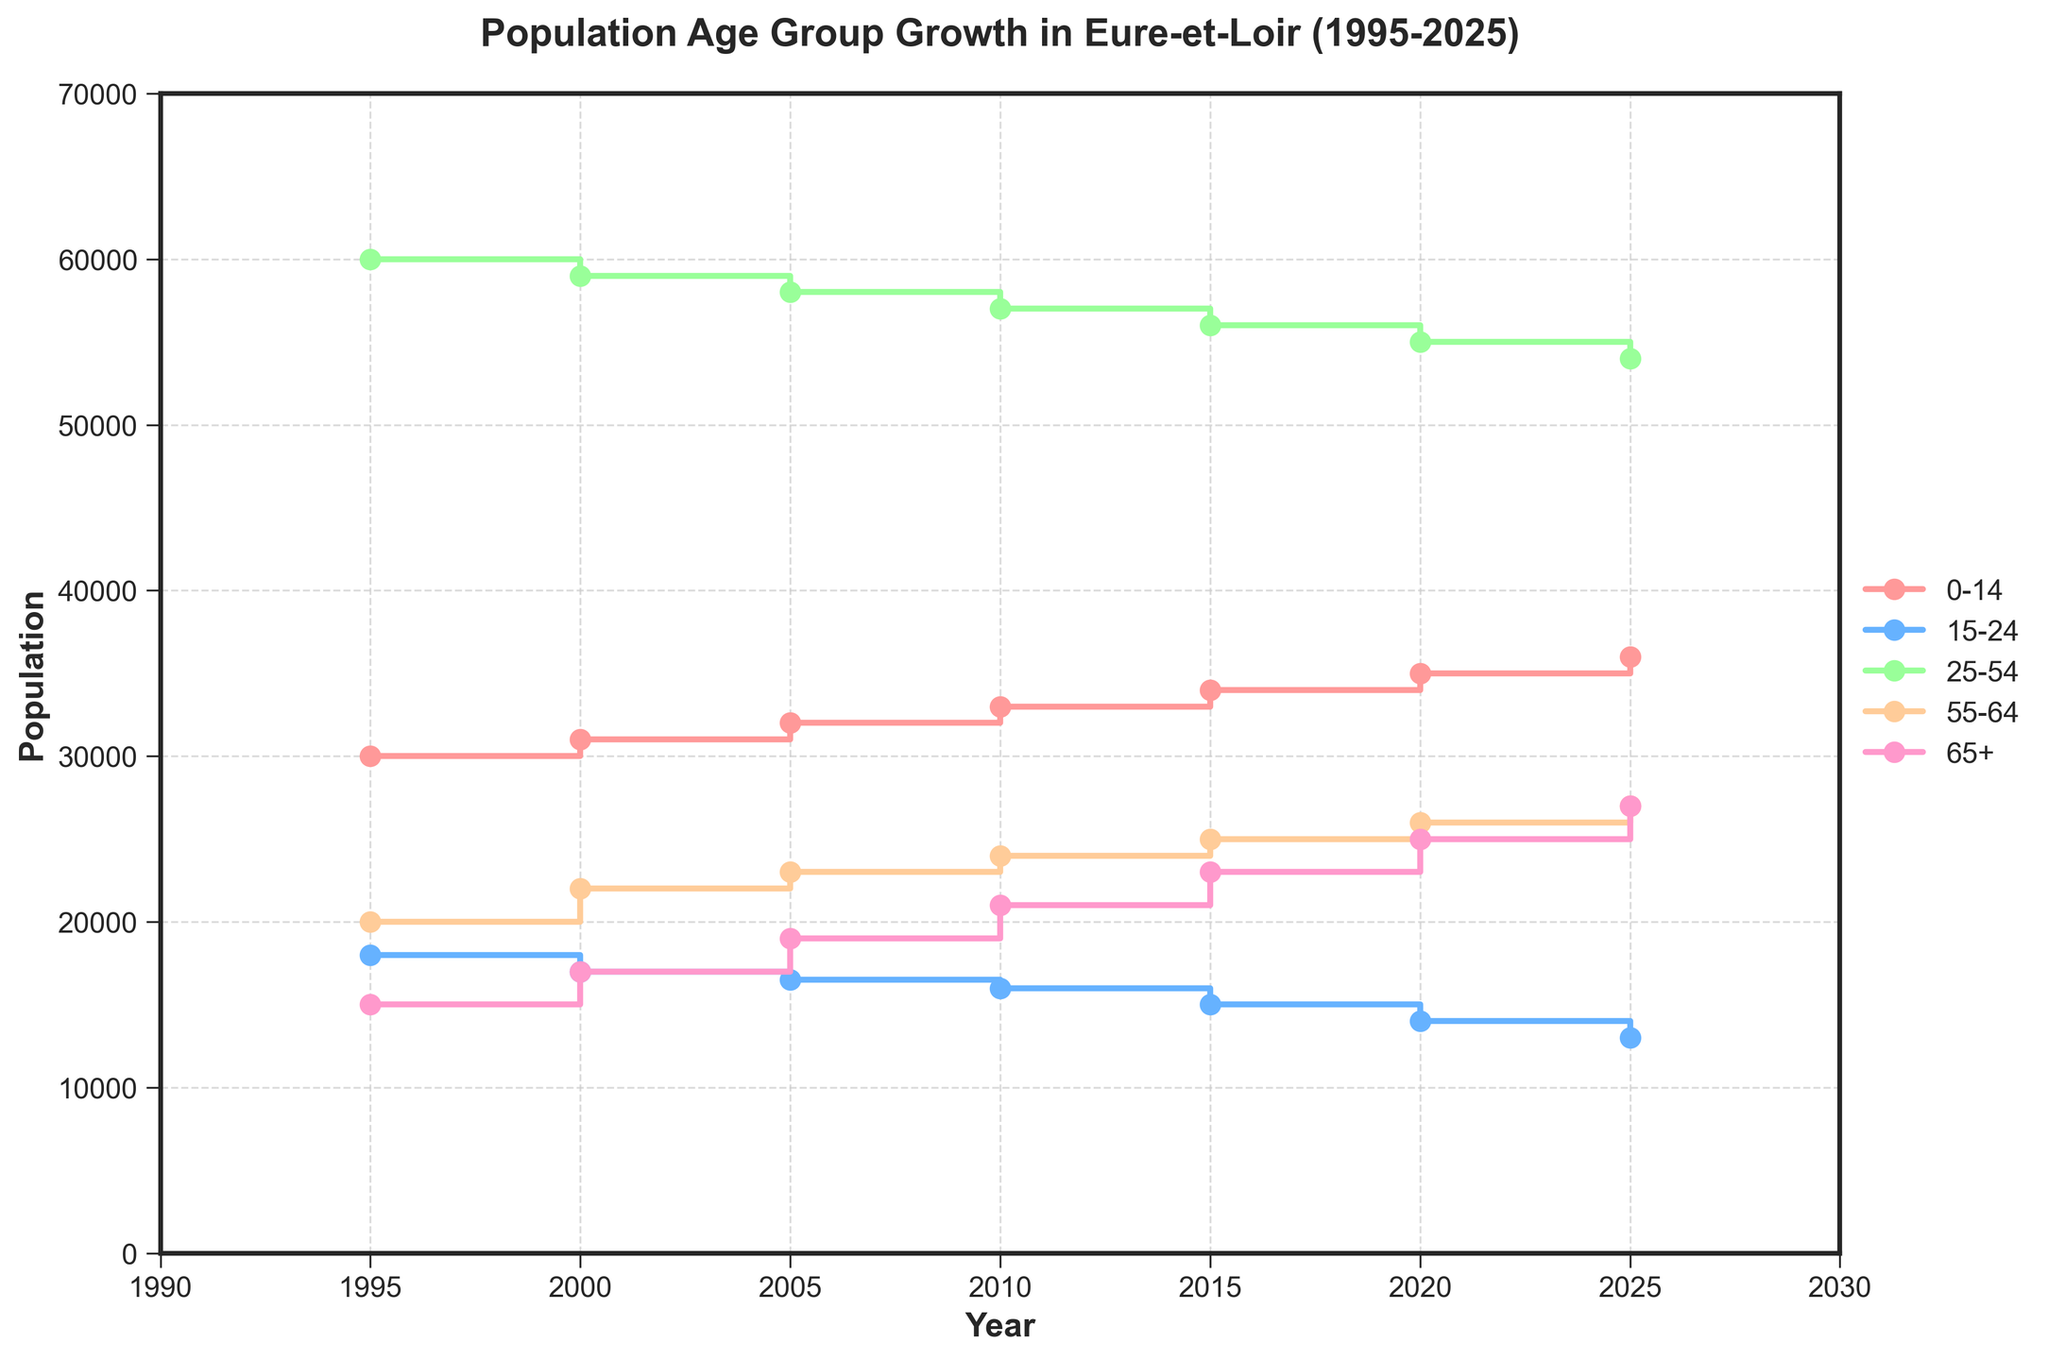What is the title of the plot? The title of the plot is typically placed at the top and in this case, it describes the main focus of the data being visualized.
Answer: Population Age Group Growth in Eure-et-Loir (1995-2025) Which age group has the highest population in 2025? The population numbers can be read directly from the end of each line on the plot for the year 2025. The group with the highest value is the one you are looking for.
Answer: 25-54 What trend can you see for the age group "65+" from 1995 to 2025? To identify the trend, observe the steps or changes in the line representing the 65+ age group from 1995 to 2025. The overall increase or decrease direction will indicate the trend.
Answer: Increasing What is the difference in population for the age group "0-14" between 1995 and 2025? Subtract the population of the "0-14" age group in 1995 from its population in 2025. Data points needed are 30000 (1995) and 36000 (2025).
Answer: 6000 Which age group has shown the greatest increase in population from 1995 to 2025? Calculate the difference in population from 1995 to 2025 for each age group and the group with the largest positive difference is the answer.
Answer: 65+ Between 2005 and 2010, did the population of the "15-24" age group increase, decrease, or stay the same? Compare the population values of the "15-24" age group between 2005 (16500) and 2010 (16000) to determine if it increased, decreased, or remained unchanged.
Answer: Decreased Can you name the colors used to represent each age group in the plot? Identify the different colors used to draw the lines representing each age group in the figure.
Answer: 0-14 (pink), 15-24 (blue), 25-54 (light green), 55-64 (peach), 65+ (light pink) Which age group had the smallest population in 2010 and what was its value? Find the population value for each age group in the year 2010 and identify the smallest one.
Answer: 15-24, 16000 